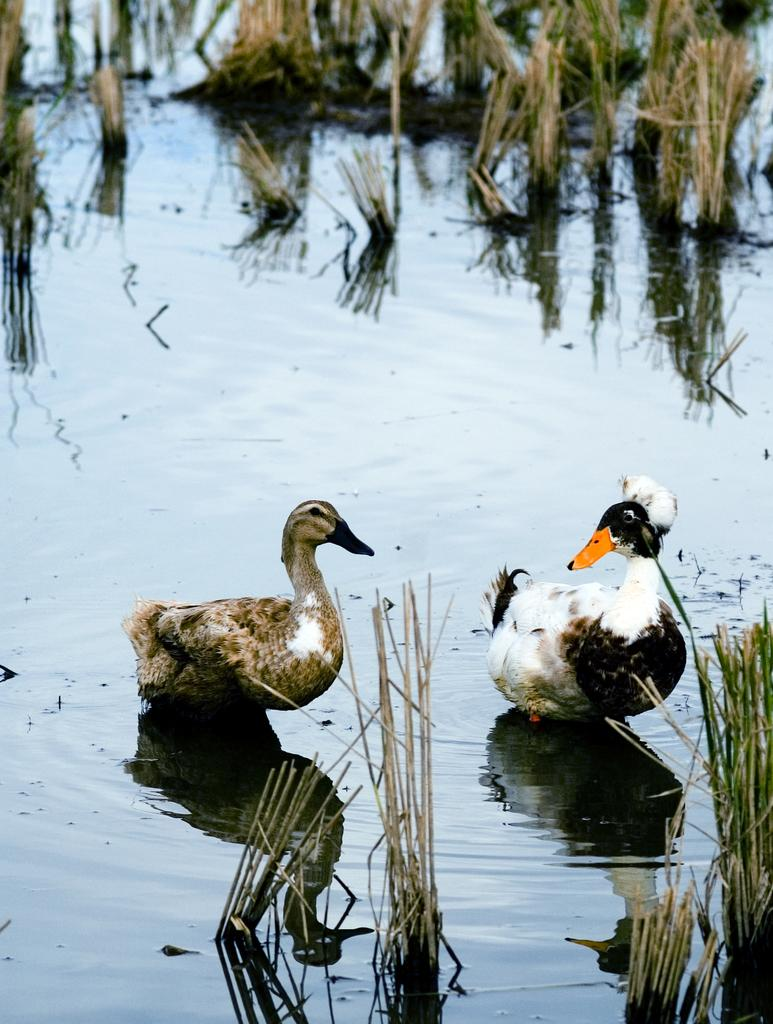How many ducks are in the image? There are two ducks in the image. What is at the bottom of the image? There is water at the bottom of the image. What else can be seen in the image besides the ducks? There are plants visible in the image. Where is the robin hiding in the image? There is no robin present in the image. What type of air is visible in the image? The image does not show any specific type of air; it simply depicts the ducks and plants in a watery environment. 